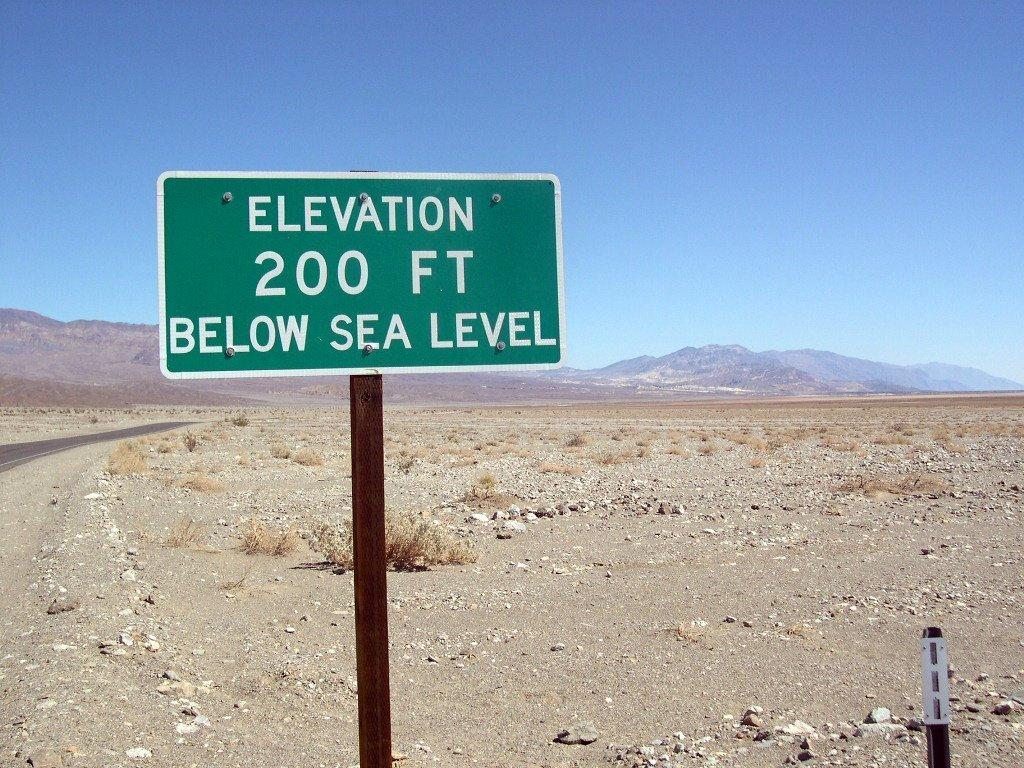<image>
Create a compact narrative representing the image presented. A green sign with the words Elevation 200 ft below sea level on it. 